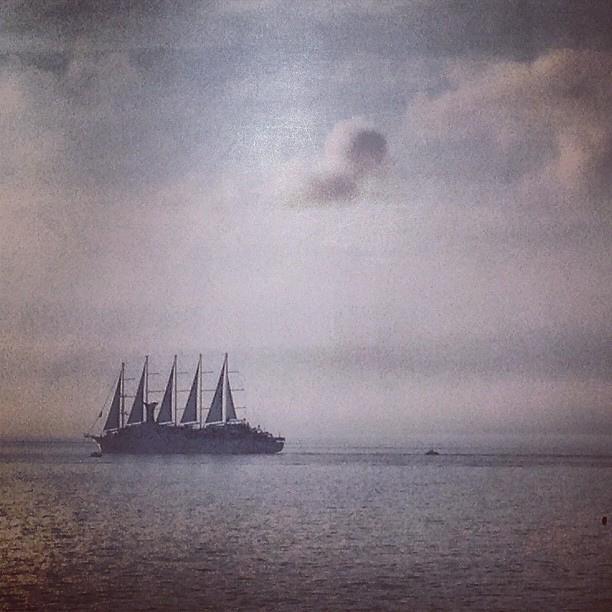How many sails does the ship have?
Give a very brief answer. 5. How many men are in the photo?
Give a very brief answer. 0. 